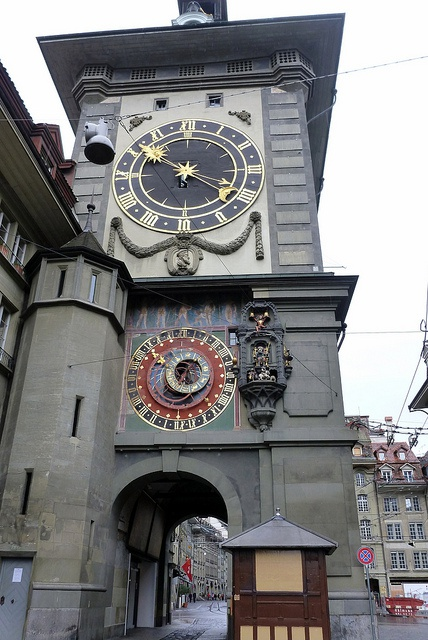Describe the objects in this image and their specific colors. I can see clock in white, gray, ivory, and darkgray tones and clock in white, brown, gray, darkgray, and black tones in this image. 